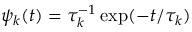<formula> <loc_0><loc_0><loc_500><loc_500>\psi _ { k } ( t ) = \tau _ { k } ^ { - 1 } \exp ( - t / \tau _ { k } )</formula> 